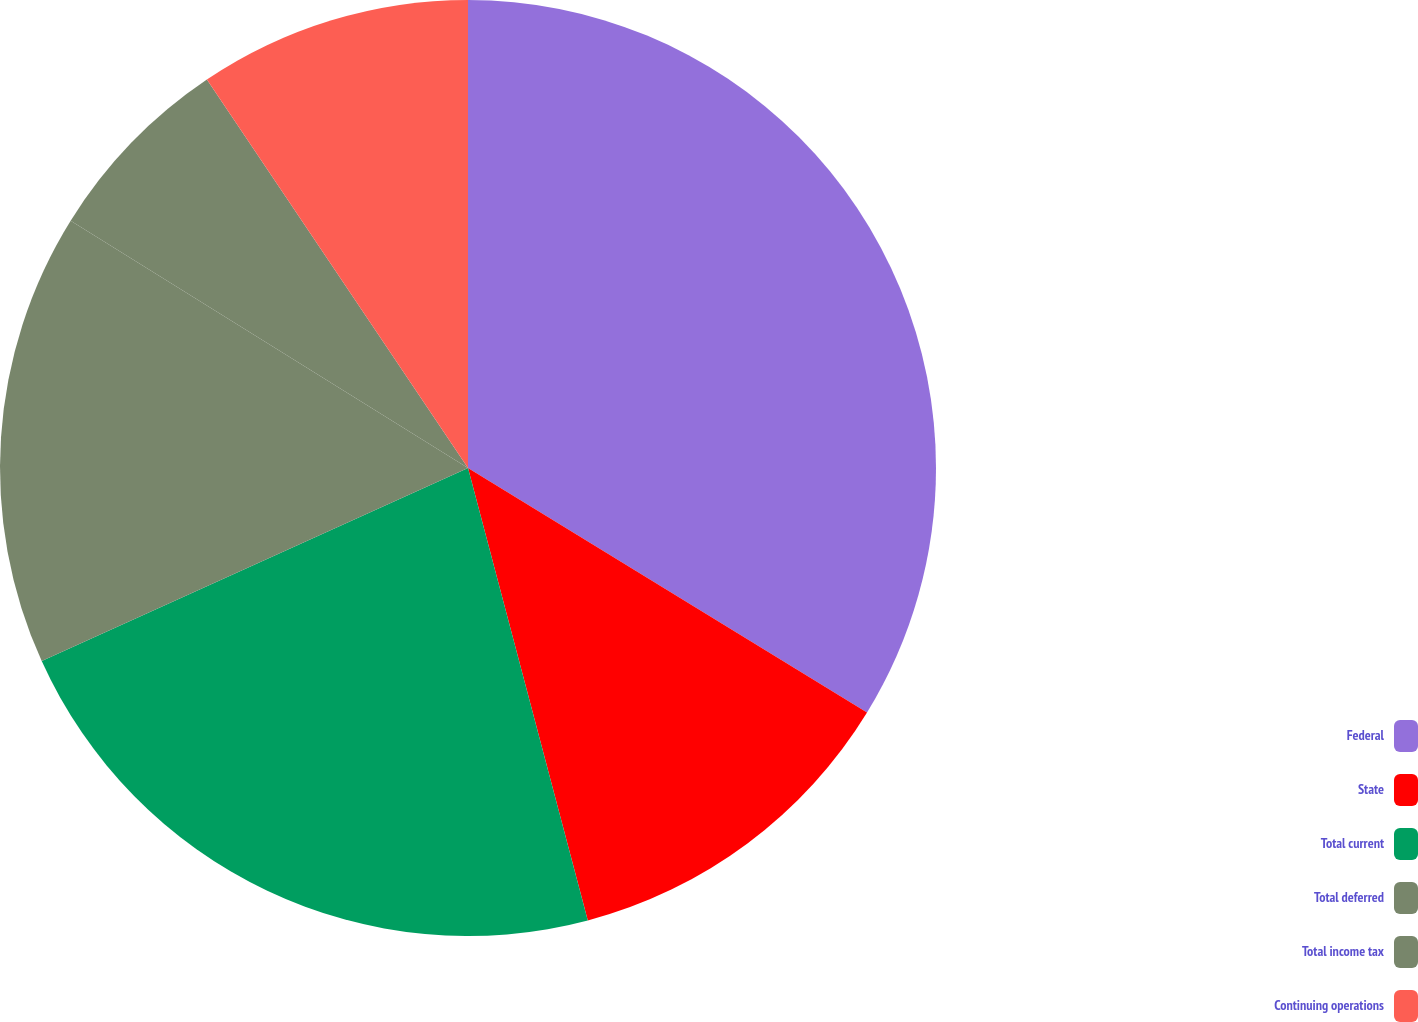Convert chart. <chart><loc_0><loc_0><loc_500><loc_500><pie_chart><fcel>Federal<fcel>State<fcel>Total current<fcel>Total deferred<fcel>Total income tax<fcel>Continuing operations<nl><fcel>33.75%<fcel>12.13%<fcel>22.35%<fcel>15.63%<fcel>6.72%<fcel>9.42%<nl></chart> 